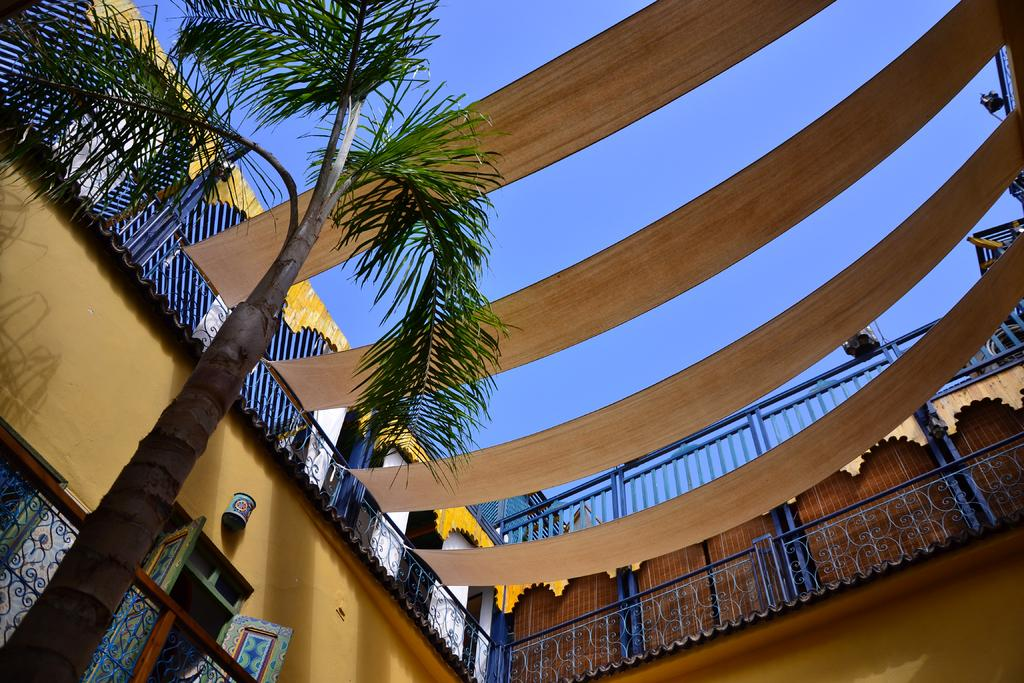What type of structures can be seen in the image? There are buildings in the image. What is the barrier surrounding the buildings? There is a fence in the image. What type of plant is present in the image? There is a tree in the image. What part of the natural environment is visible in the image? The sky is visible in the image. What is the price of the quilt hanging on the tree in the image? There is no quilt present in the image, and therefore no price can be determined. 